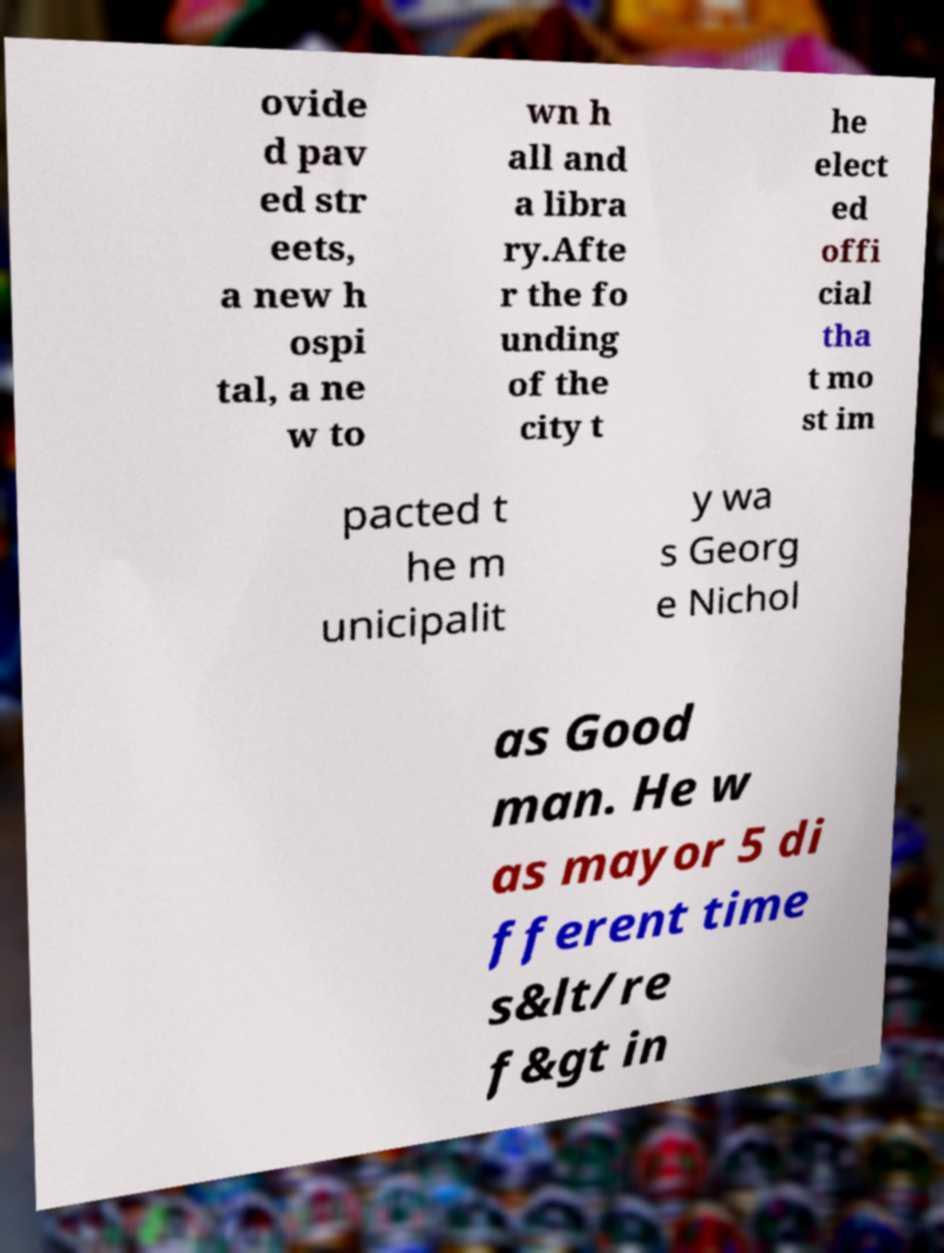There's text embedded in this image that I need extracted. Can you transcribe it verbatim? ovide d pav ed str eets, a new h ospi tal, a ne w to wn h all and a libra ry.Afte r the fo unding of the city t he elect ed offi cial tha t mo st im pacted t he m unicipalit y wa s Georg e Nichol as Good man. He w as mayor 5 di fferent time s&lt/re f&gt in 